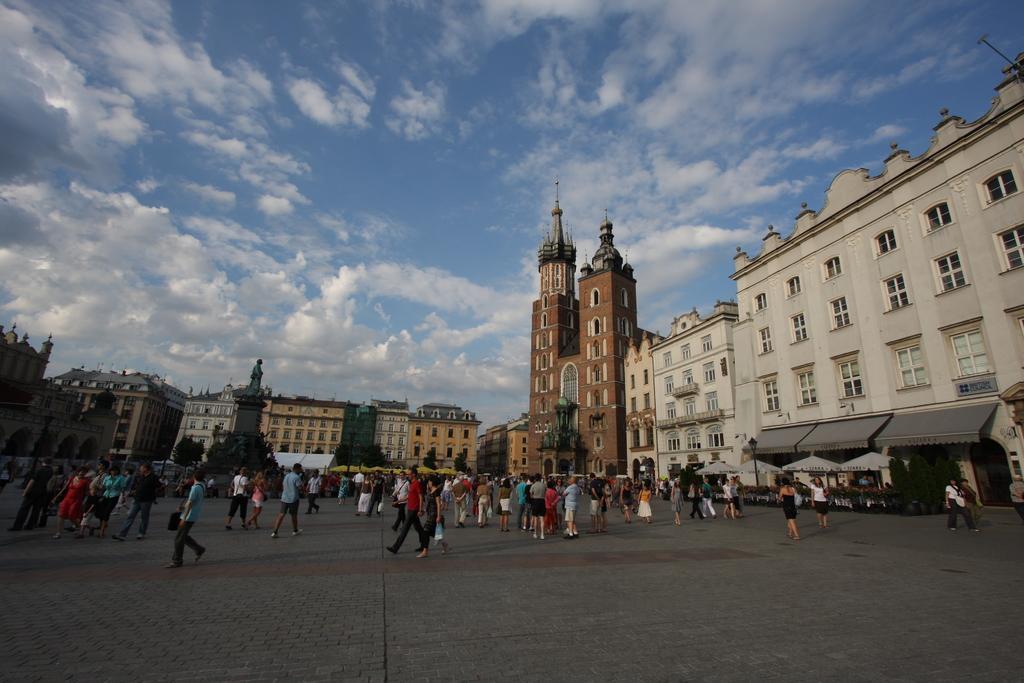Can you describe this image briefly? In the picture we can see a path with many people are walking and in the background, we can see many buildings with windows and in the background we can see the sky with clouds. 